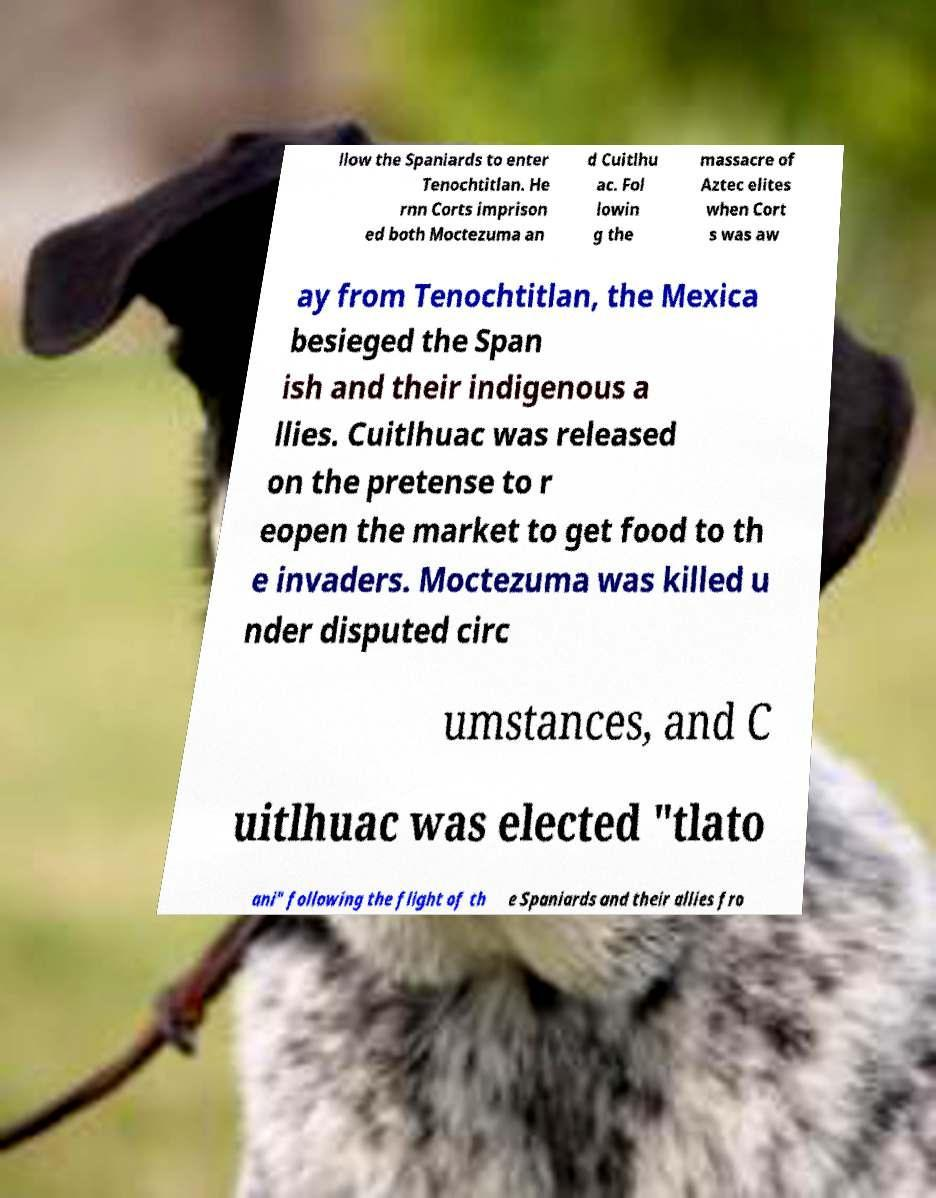Could you extract and type out the text from this image? llow the Spaniards to enter Tenochtitlan. He rnn Corts imprison ed both Moctezuma an d Cuitlhu ac. Fol lowin g the massacre of Aztec elites when Cort s was aw ay from Tenochtitlan, the Mexica besieged the Span ish and their indigenous a llies. Cuitlhuac was released on the pretense to r eopen the market to get food to th e invaders. Moctezuma was killed u nder disputed circ umstances, and C uitlhuac was elected "tlato ani" following the flight of th e Spaniards and their allies fro 